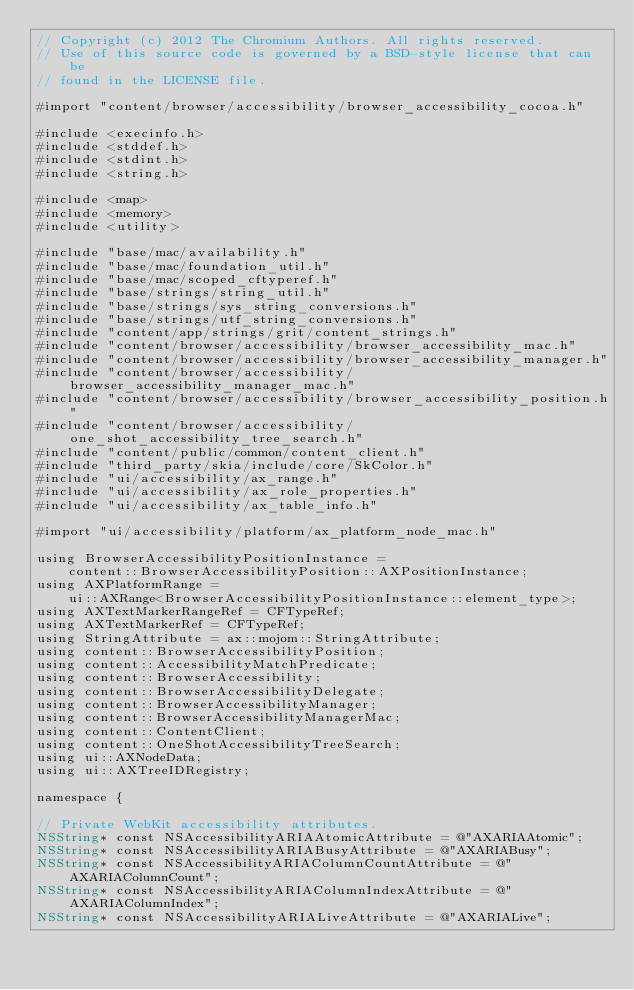<code> <loc_0><loc_0><loc_500><loc_500><_ObjectiveC_>// Copyright (c) 2012 The Chromium Authors. All rights reserved.
// Use of this source code is governed by a BSD-style license that can be
// found in the LICENSE file.

#import "content/browser/accessibility/browser_accessibility_cocoa.h"

#include <execinfo.h>
#include <stddef.h>
#include <stdint.h>
#include <string.h>

#include <map>
#include <memory>
#include <utility>

#include "base/mac/availability.h"
#include "base/mac/foundation_util.h"
#include "base/mac/scoped_cftyperef.h"
#include "base/strings/string_util.h"
#include "base/strings/sys_string_conversions.h"
#include "base/strings/utf_string_conversions.h"
#include "content/app/strings/grit/content_strings.h"
#include "content/browser/accessibility/browser_accessibility_mac.h"
#include "content/browser/accessibility/browser_accessibility_manager.h"
#include "content/browser/accessibility/browser_accessibility_manager_mac.h"
#include "content/browser/accessibility/browser_accessibility_position.h"
#include "content/browser/accessibility/one_shot_accessibility_tree_search.h"
#include "content/public/common/content_client.h"
#include "third_party/skia/include/core/SkColor.h"
#include "ui/accessibility/ax_range.h"
#include "ui/accessibility/ax_role_properties.h"
#include "ui/accessibility/ax_table_info.h"

#import "ui/accessibility/platform/ax_platform_node_mac.h"

using BrowserAccessibilityPositionInstance =
    content::BrowserAccessibilityPosition::AXPositionInstance;
using AXPlatformRange =
    ui::AXRange<BrowserAccessibilityPositionInstance::element_type>;
using AXTextMarkerRangeRef = CFTypeRef;
using AXTextMarkerRef = CFTypeRef;
using StringAttribute = ax::mojom::StringAttribute;
using content::BrowserAccessibilityPosition;
using content::AccessibilityMatchPredicate;
using content::BrowserAccessibility;
using content::BrowserAccessibilityDelegate;
using content::BrowserAccessibilityManager;
using content::BrowserAccessibilityManagerMac;
using content::ContentClient;
using content::OneShotAccessibilityTreeSearch;
using ui::AXNodeData;
using ui::AXTreeIDRegistry;

namespace {

// Private WebKit accessibility attributes.
NSString* const NSAccessibilityARIAAtomicAttribute = @"AXARIAAtomic";
NSString* const NSAccessibilityARIABusyAttribute = @"AXARIABusy";
NSString* const NSAccessibilityARIAColumnCountAttribute = @"AXARIAColumnCount";
NSString* const NSAccessibilityARIAColumnIndexAttribute = @"AXARIAColumnIndex";
NSString* const NSAccessibilityARIALiveAttribute = @"AXARIALive";</code> 